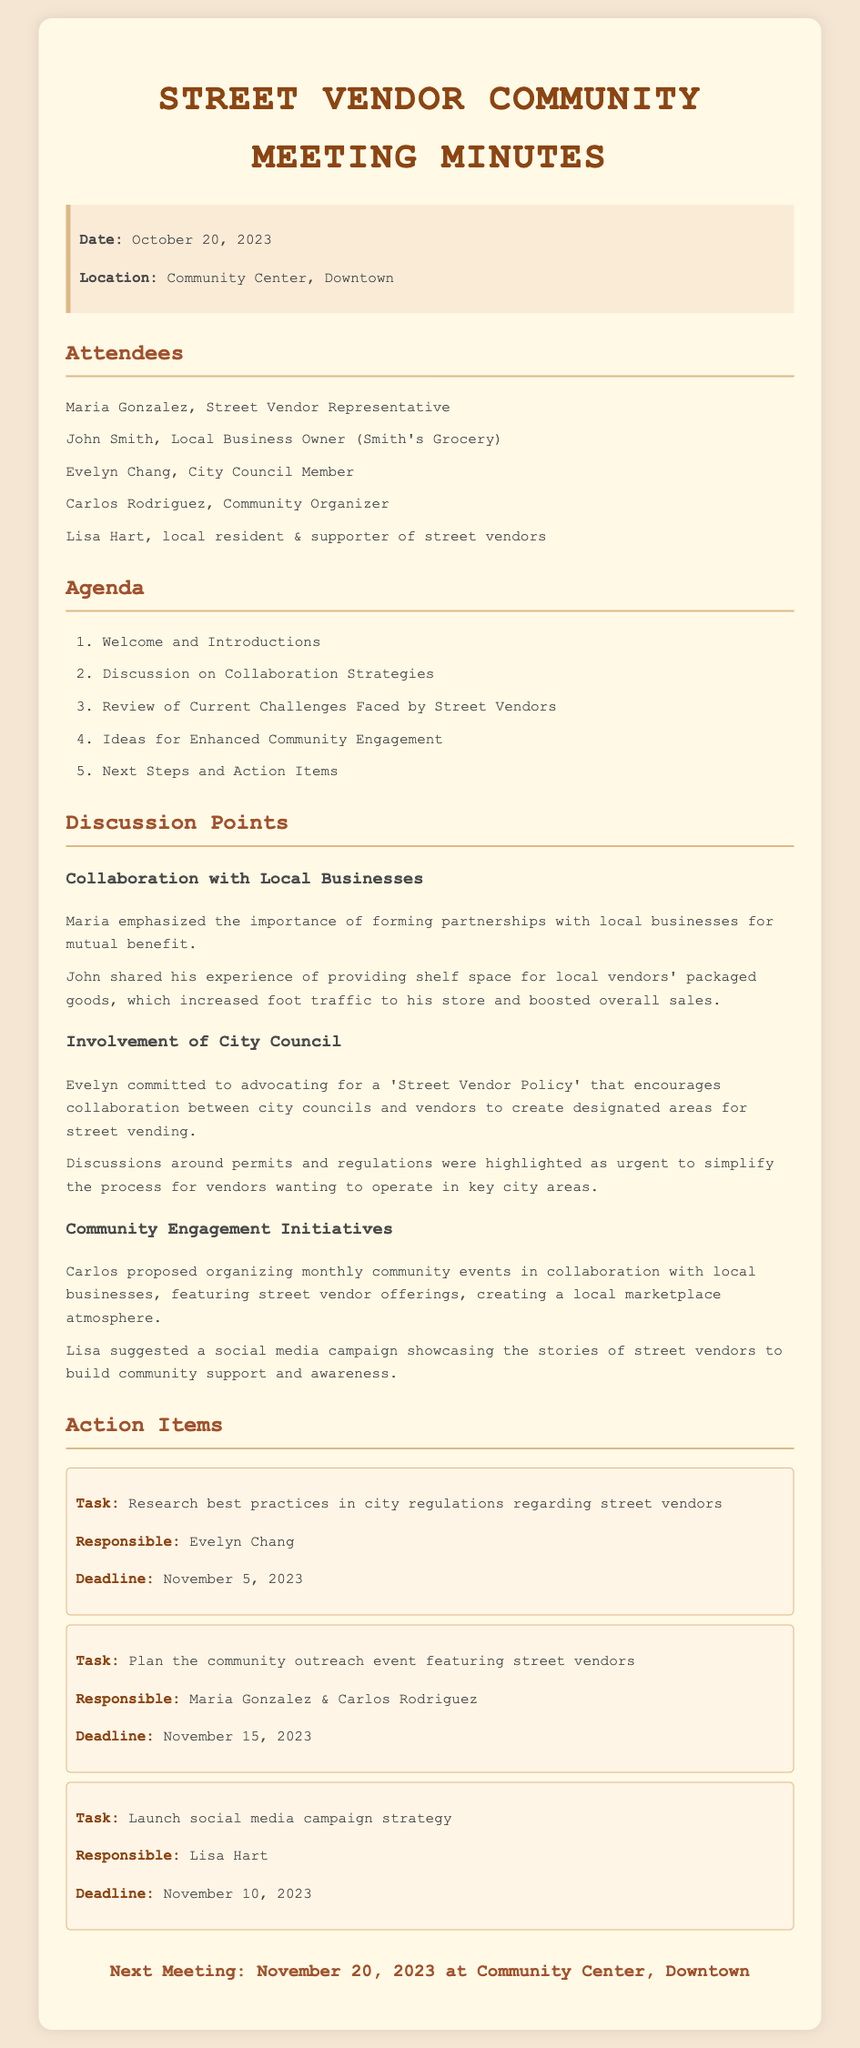What was the date of the meeting? The meeting date is explicitly mentioned in the document's info box.
Answer: October 20, 2023 Who represented the street vendors at the meeting? The document lists Maria Gonzalez as the Street Vendor Representative in the attendees section.
Answer: Maria Gonzalez What is one initiative proposed by Carlos? The discussion points include suggestions, and specifically, Carlos proposed organizing monthly community events.
Answer: Organizing monthly community events Who is responsible for researching best practices in city regulations? The action items clearly outline responsibilities, and Evelyn Chang is tasked with this research.
Answer: Evelyn Chang What is the deadline for the social media campaign strategy? Each action item has a specified deadline, which can be located under the corresponding task.
Answer: November 10, 2023 What type of policy did Evelyn commit to advocate for? The document states Evelyn advocated for a 'Street Vendor Policy' during the meeting discussion.
Answer: Street Vendor Policy How often are the proposed community events planned to occur? Carlos’s proposal mentioned organizing events on a monthly basis.
Answer: Monthly When is the next meeting scheduled? The last section of the document specifies the date of the next meeting.
Answer: November 20, 2023 